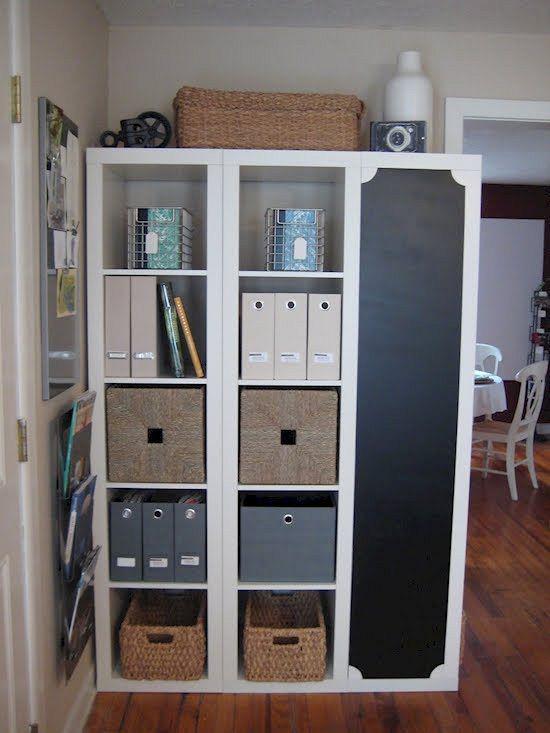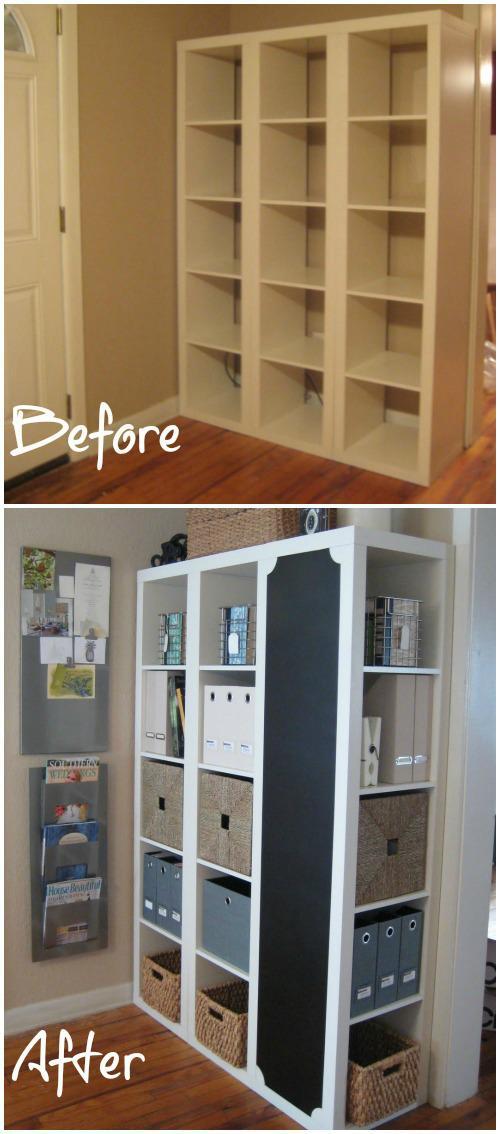The first image is the image on the left, the second image is the image on the right. Considering the images on both sides, is "One of the bookcases show is adjacent to some windows." valid? Answer yes or no. No. The first image is the image on the left, the second image is the image on the right. Examine the images to the left and right. Is the description "there is a white shelving unit with two whicker cubby boxes on the bottom row and a chalk board on the right" accurate? Answer yes or no. Yes. 